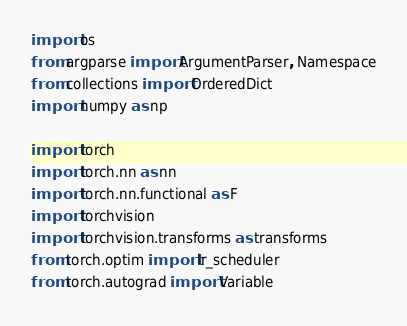<code> <loc_0><loc_0><loc_500><loc_500><_Python_>import os
from argparse import ArgumentParser, Namespace
from collections import OrderedDict
import numpy as np

import torch
import torch.nn as nn
import torch.nn.functional as F
import torchvision
import torchvision.transforms as transforms
from torch.optim import lr_scheduler
from torch.autograd import Variable</code> 